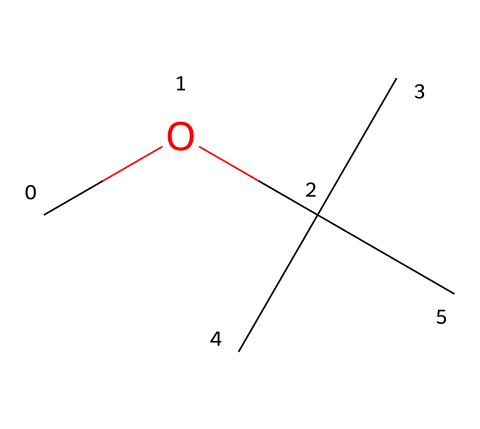what is the molecular formula of methyl tert-butyl ether? The SMILES representation reveals that the chemical consists of one carbon atom from the methyl (CH3) group and four carbon atoms from the tert-butyl group, giving a total of five carbon atoms. Additionally, there are twelve hydrogen atoms overall and one oxygen atom. Therefore, the molecular formula is C5H12O.
Answer: C5H12O how many hydrogen atoms are present in methyl tert-butyl ether? By examining the SMILES structure, we see a total of 12 hydrogen atoms, which is derived from the five carbon atoms in the molecule and their saturation with hydrogen.
Answer: 12 what type of chemical bond connects the carbon and oxygen atoms in methyl tert-butyl ether? In typical ethers, including methyl tert-butyl ether, the bond between the carbon and oxygen is a single covalent bond (C-O bond). This is determined by the presence of oxygen attached to carbon atoms without any additional functional groups that would alter the bond type.
Answer: single covalent bond how does the branching in methyl tert-butyl ether affect its physical properties? The branching of the tert-butyl group in methyl tert-butyl ether leads to improved volatility and lower boiling point compared to straight-chain ethers. This characteristic is a result of the steric hindrance that reduces the intermolecular forces between molecules, affecting its physical properties like boiling point and solubility.
Answer: lowers boiling point what is the role of methyl tert-butyl ether as a gasoline additive? Methyl tert-butyl ether is used as an oxygenate in gasoline, which means it helps to increase the oxygen content in fuel combustion, leading to more efficient burning and reduced emissions. This function is important for improving air quality and compliance with environmental regulations.
Answer: oxygenate does methyl tert-butyl ether contain any functional groups? Yes, methyl tert-butyl ether contains an ether functional group, characterized by the presence of an oxygen atom bonded to two alkyl or aryl groups. This is indicated by the structure where oxygen is connected to the methyl and tert-butyl groups.
Answer: ether functional group 